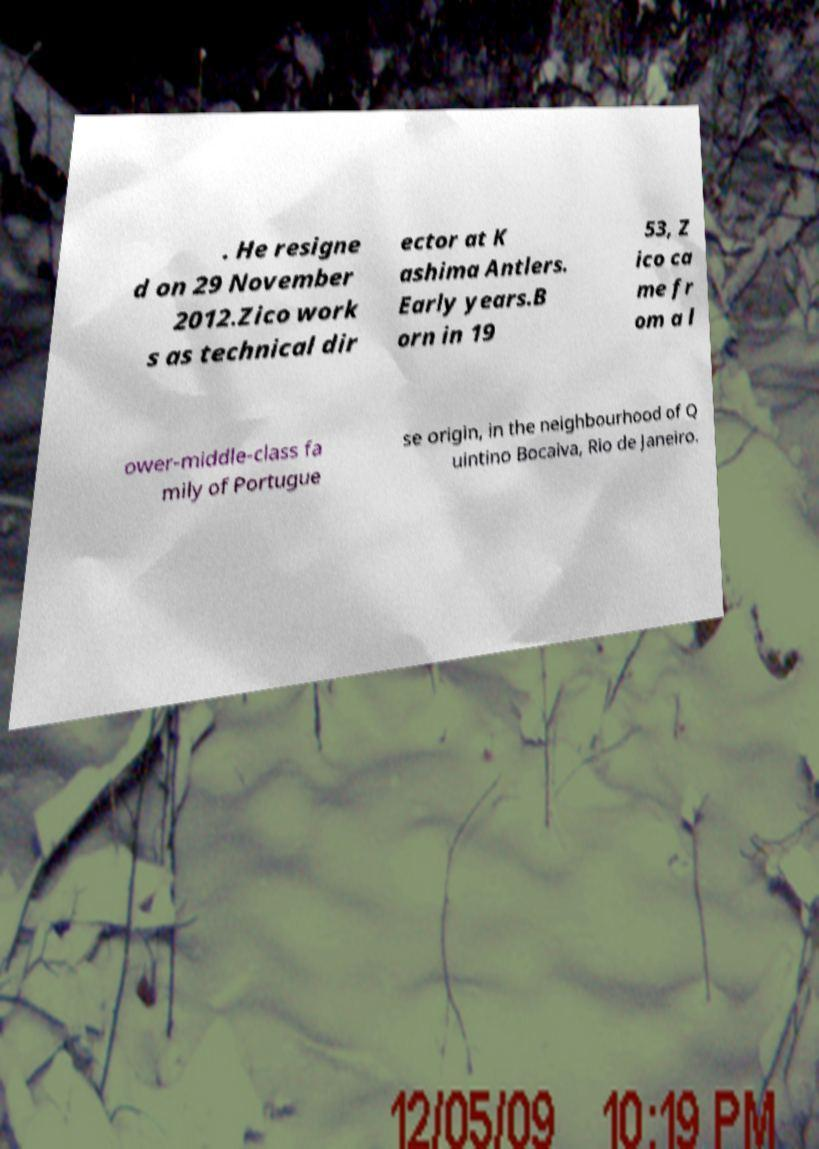Can you read and provide the text displayed in the image?This photo seems to have some interesting text. Can you extract and type it out for me? . He resigne d on 29 November 2012.Zico work s as technical dir ector at K ashima Antlers. Early years.B orn in 19 53, Z ico ca me fr om a l ower-middle-class fa mily of Portugue se origin, in the neighbourhood of Q uintino Bocaiva, Rio de Janeiro. 